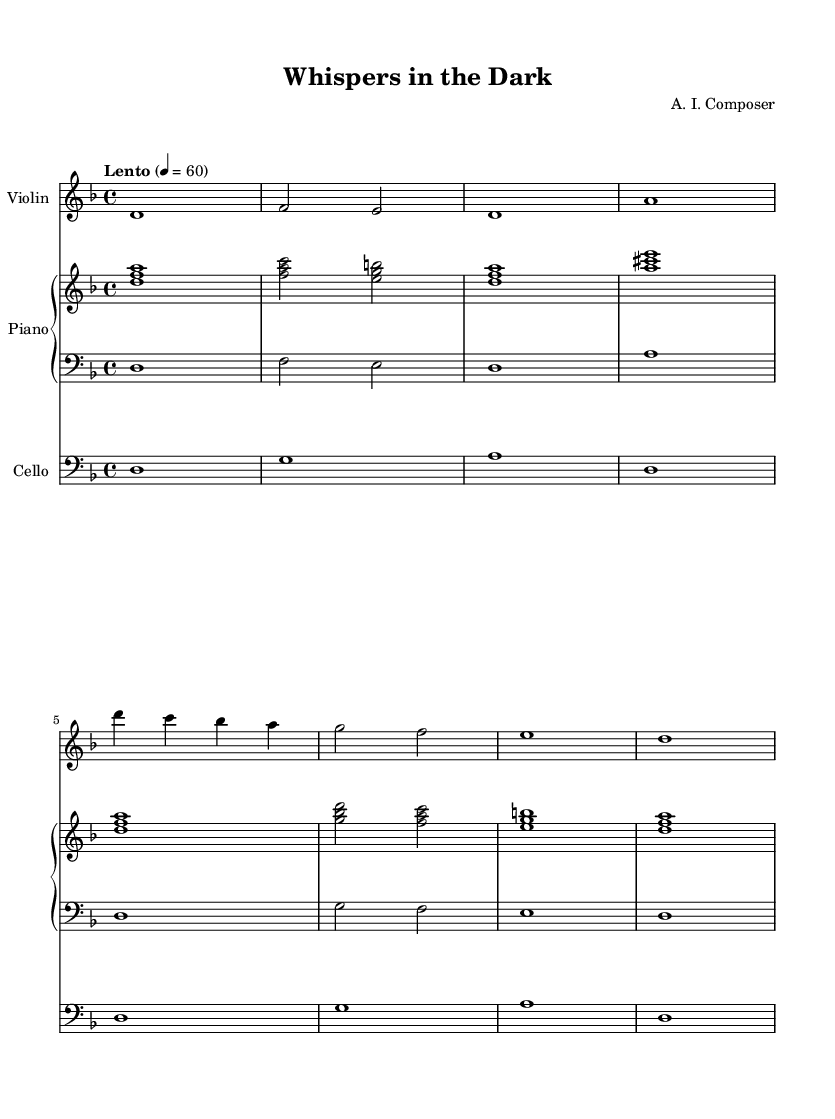What is the key signature of this music? The key signature shows two flats (B and E), indicating that the music is in the key of D minor.
Answer: D minor What is the time signature of this music? The time signature displayed at the beginning of the sheet music is 4/4, meaning there are four beats in a measure and the quarter note gets one beat.
Answer: 4/4 What is the tempo indication for this piece? The tempo marking states "Lento" and indicates 60 beats per minute, suggesting a slow pace for the music.
Answer: Lento, 60 How many measures are there in the violin part? By counting each line in the violin staff, there are 8 measures total in the violin part.
Answer: 8 Which instrument plays the lowest range in this score? The cello part, which is written in the bass clef, plays the lowest range compared to the violin and piano parts.
Answer: Cello What are the two chords played in the first measure of the piano upper part? The first measure displays the chord made up of the notes D, F, and A, which collectively form a D minor chord.
Answer: D minor Which instruments feature prominently in creating the haunting atmosphere of this music? The combination of the violin, piano, and cello, with their layered harmonies and melodies, contributes significantly to the atmospheric quality that is characteristic of classic horror film soundtracks.
Answer: Violin, Piano, Cello 